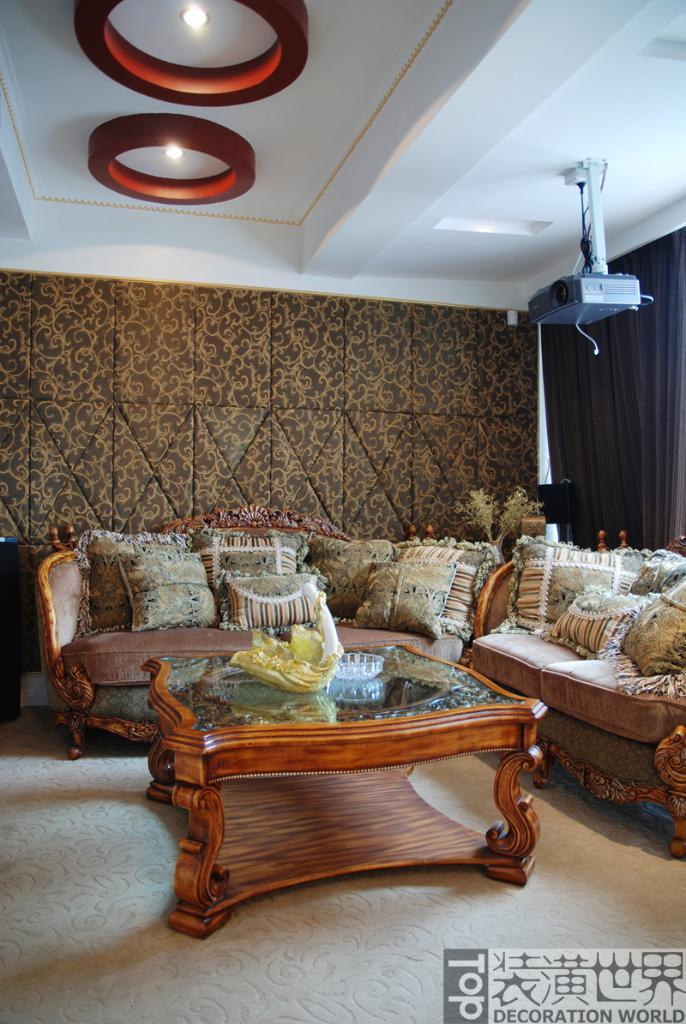What type of furniture is in the middle of the image? There is a sofa in the middle of the image. Can you describe the positioning of the sofa in the image? The sofa is in the middle of the image. What is attached to the top of the sofa? There are lights on the sofa. Where exactly are the lights located on the sofa? The lights are at the top of the sofa. How many apples can be seen growing in the field behind the sofa in the image? There are no apples or fields present in the image; it only features a sofa with lights on it. What type of fruit is visible on the banana tree next to the sofa in the image? There is no banana tree or fruit present in the image; it only features a sofa with lights on it. 